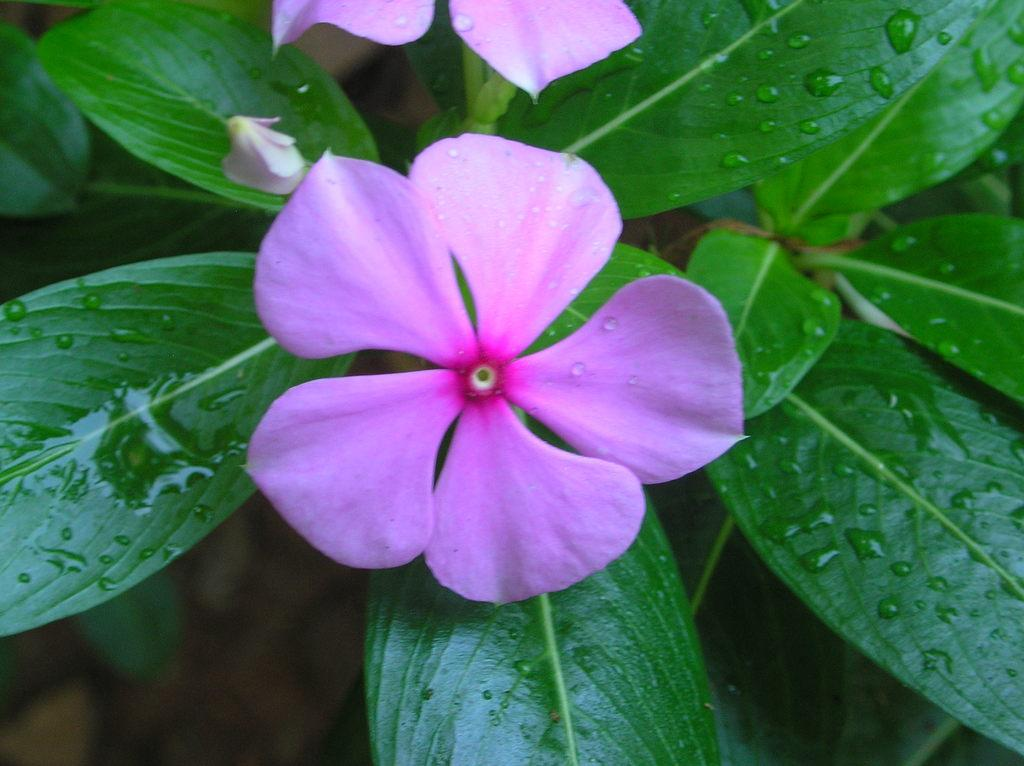What type of flowers can be seen in the image? There are two pink flowers in the image. What color are the leaves in the image? The leaves in the image are green. How many pies are being driven in the image? There are no pies or driving depicted in the image; it features two pink flowers and green leaves. 